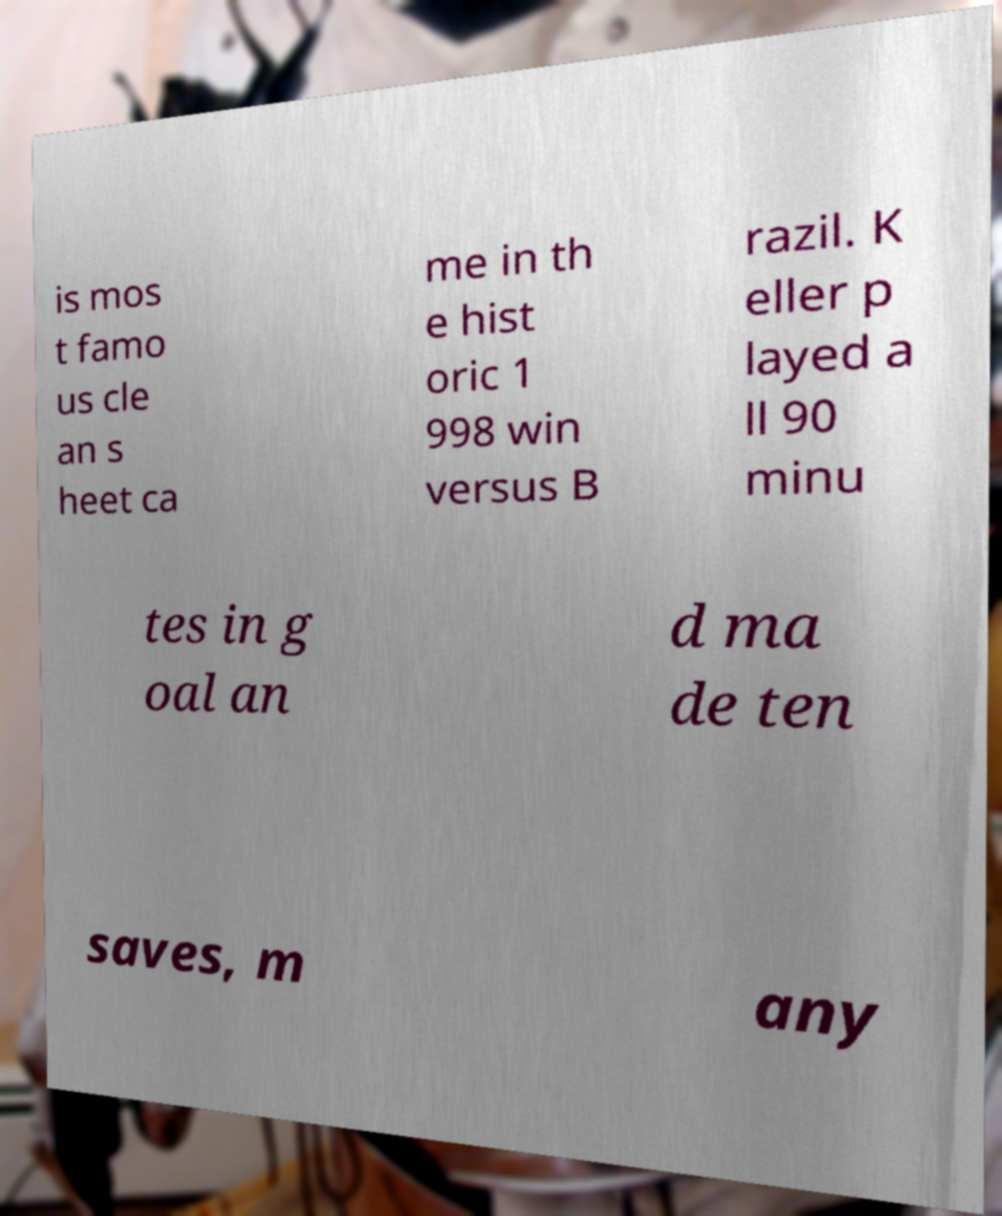Please identify and transcribe the text found in this image. is mos t famo us cle an s heet ca me in th e hist oric 1 998 win versus B razil. K eller p layed a ll 90 minu tes in g oal an d ma de ten saves, m any 